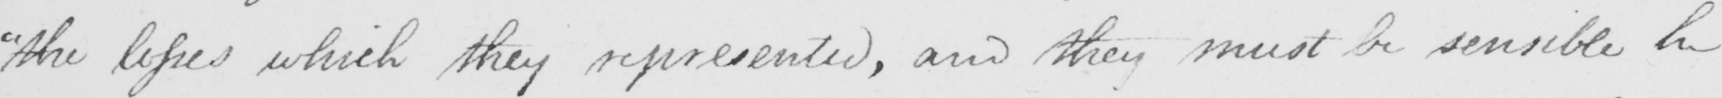What text is written in this handwritten line? " the losses which they represented , and they must be sensible he 